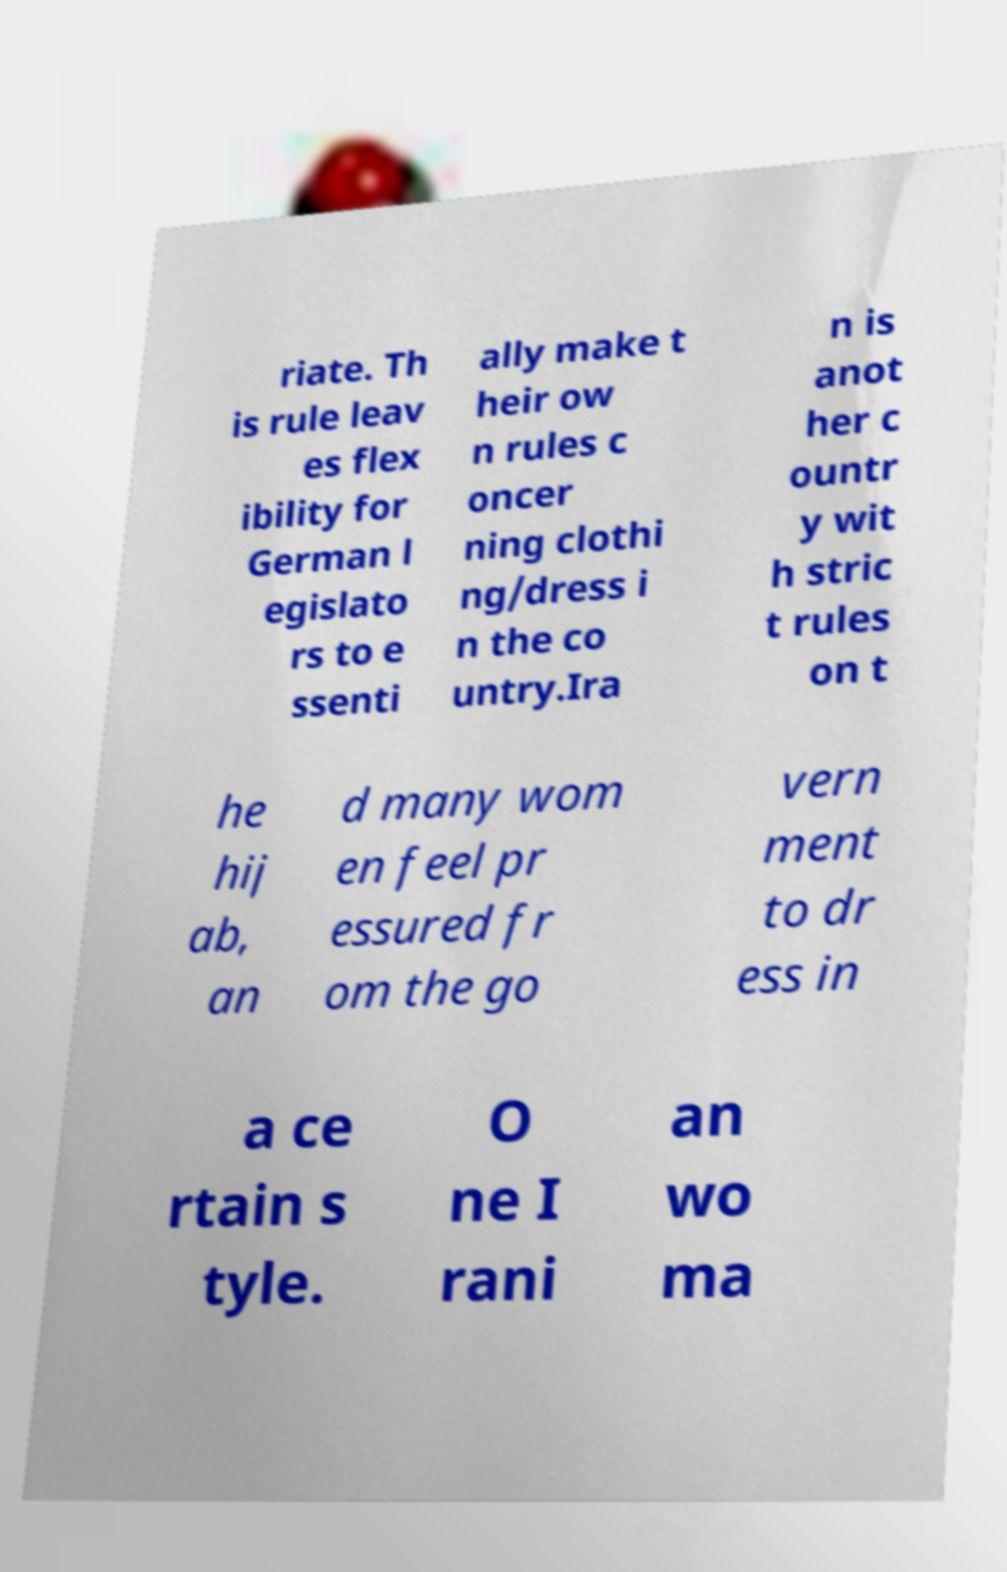What messages or text are displayed in this image? I need them in a readable, typed format. riate. Th is rule leav es flex ibility for German l egislato rs to e ssenti ally make t heir ow n rules c oncer ning clothi ng/dress i n the co untry.Ira n is anot her c ountr y wit h stric t rules on t he hij ab, an d many wom en feel pr essured fr om the go vern ment to dr ess in a ce rtain s tyle. O ne I rani an wo ma 